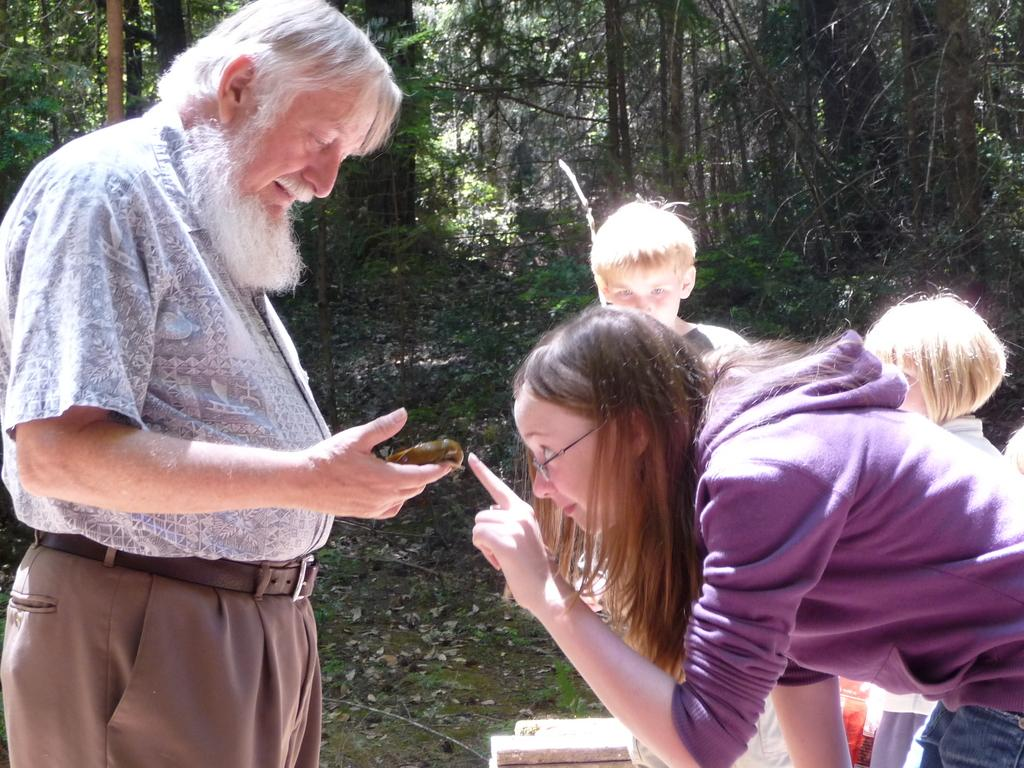How many people and kids are in the image? There are two persons and two kids standing in the front of the image. What are the people holding in the image? One person is holding something. What can be seen in the background of the image? There are trees in the background of the image. What type of flame can be seen coming from the oven in the image? There is no oven or flame present in the image. How many women are visible in the image? The provided facts do not specify the gender of the persons in the image, so we cannot determine the number of women. 